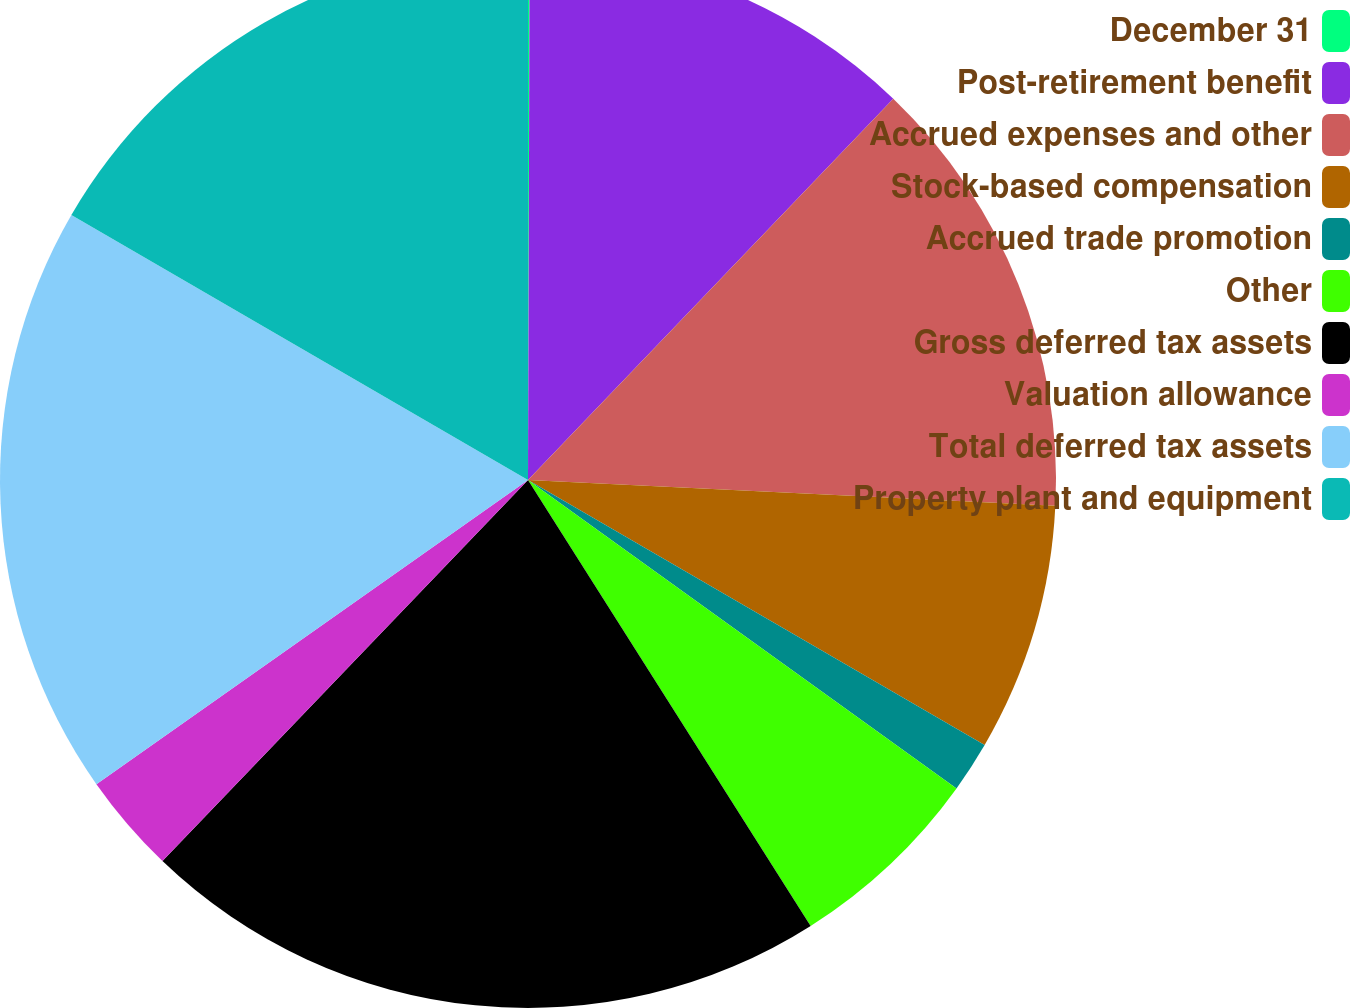Convert chart to OTSL. <chart><loc_0><loc_0><loc_500><loc_500><pie_chart><fcel>December 31<fcel>Post-retirement benefit<fcel>Accrued expenses and other<fcel>Stock-based compensation<fcel>Accrued trade promotion<fcel>Other<fcel>Gross deferred tax assets<fcel>Valuation allowance<fcel>Total deferred tax assets<fcel>Property plant and equipment<nl><fcel>0.05%<fcel>12.11%<fcel>13.62%<fcel>7.59%<fcel>1.56%<fcel>6.08%<fcel>21.16%<fcel>3.06%<fcel>18.14%<fcel>16.63%<nl></chart> 